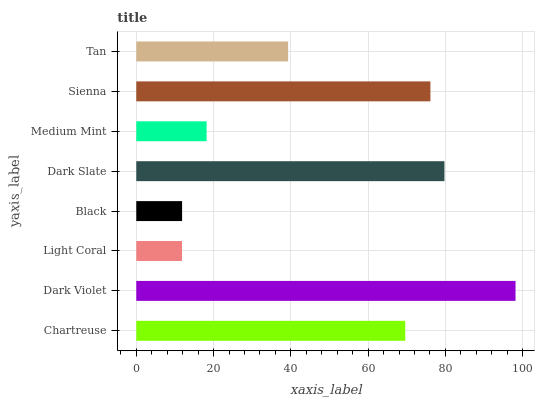Is Light Coral the minimum?
Answer yes or no. Yes. Is Dark Violet the maximum?
Answer yes or no. Yes. Is Dark Violet the minimum?
Answer yes or no. No. Is Light Coral the maximum?
Answer yes or no. No. Is Dark Violet greater than Light Coral?
Answer yes or no. Yes. Is Light Coral less than Dark Violet?
Answer yes or no. Yes. Is Light Coral greater than Dark Violet?
Answer yes or no. No. Is Dark Violet less than Light Coral?
Answer yes or no. No. Is Chartreuse the high median?
Answer yes or no. Yes. Is Tan the low median?
Answer yes or no. Yes. Is Dark Slate the high median?
Answer yes or no. No. Is Chartreuse the low median?
Answer yes or no. No. 